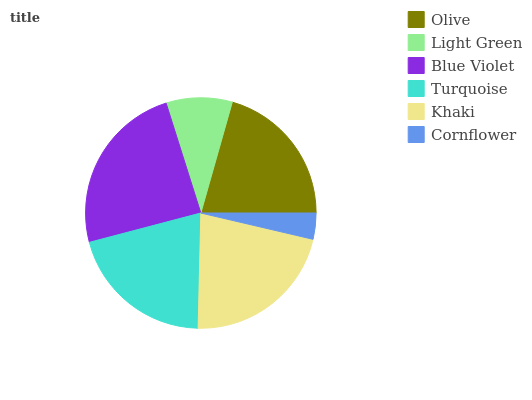Is Cornflower the minimum?
Answer yes or no. Yes. Is Blue Violet the maximum?
Answer yes or no. Yes. Is Light Green the minimum?
Answer yes or no. No. Is Light Green the maximum?
Answer yes or no. No. Is Olive greater than Light Green?
Answer yes or no. Yes. Is Light Green less than Olive?
Answer yes or no. Yes. Is Light Green greater than Olive?
Answer yes or no. No. Is Olive less than Light Green?
Answer yes or no. No. Is Olive the high median?
Answer yes or no. Yes. Is Turquoise the low median?
Answer yes or no. Yes. Is Light Green the high median?
Answer yes or no. No. Is Light Green the low median?
Answer yes or no. No. 